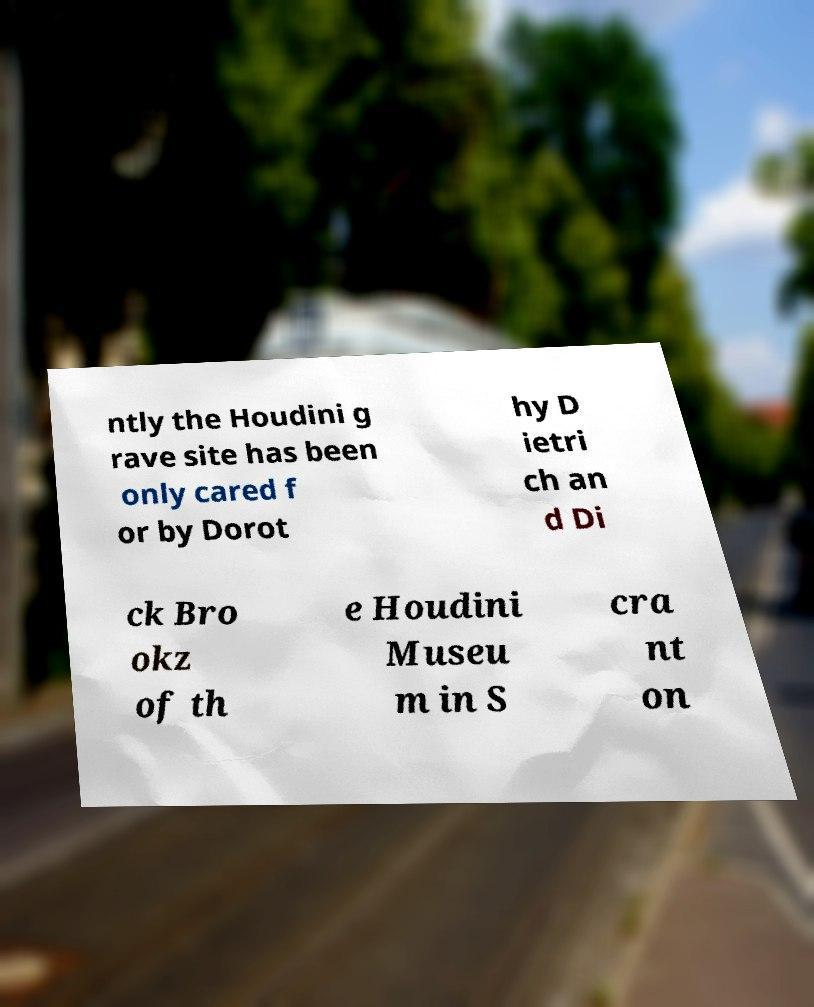Could you extract and type out the text from this image? ntly the Houdini g rave site has been only cared f or by Dorot hy D ietri ch an d Di ck Bro okz of th e Houdini Museu m in S cra nt on 